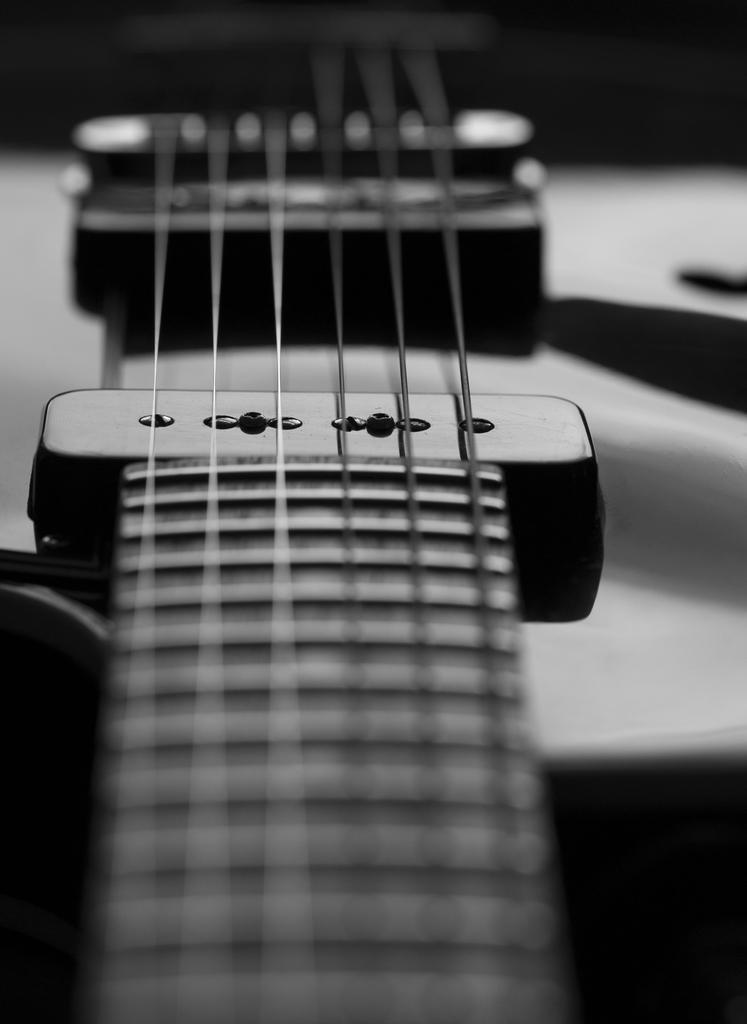Please provide a concise description of this image. The picture consists of a guitar with strings. 